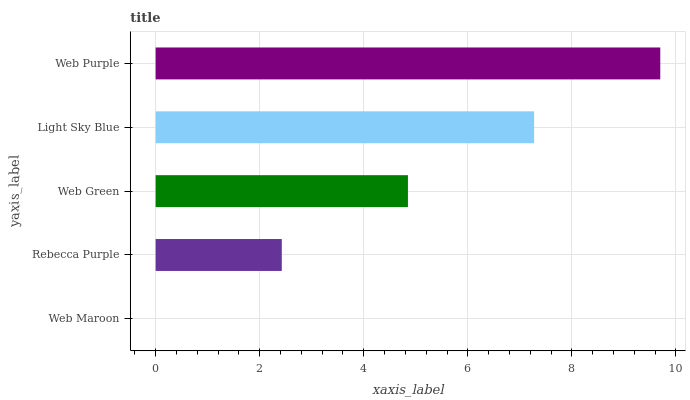Is Web Maroon the minimum?
Answer yes or no. Yes. Is Web Purple the maximum?
Answer yes or no. Yes. Is Rebecca Purple the minimum?
Answer yes or no. No. Is Rebecca Purple the maximum?
Answer yes or no. No. Is Rebecca Purple greater than Web Maroon?
Answer yes or no. Yes. Is Web Maroon less than Rebecca Purple?
Answer yes or no. Yes. Is Web Maroon greater than Rebecca Purple?
Answer yes or no. No. Is Rebecca Purple less than Web Maroon?
Answer yes or no. No. Is Web Green the high median?
Answer yes or no. Yes. Is Web Green the low median?
Answer yes or no. Yes. Is Web Purple the high median?
Answer yes or no. No. Is Rebecca Purple the low median?
Answer yes or no. No. 